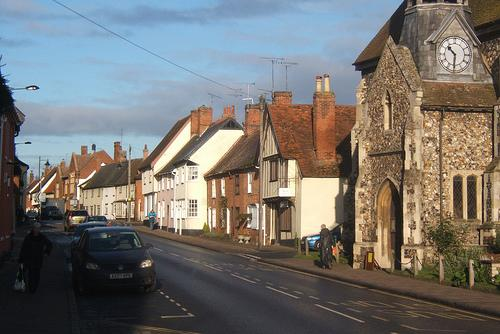What is the person on the left standing next to? Please explain your reasoning. car. The person is by a car. 